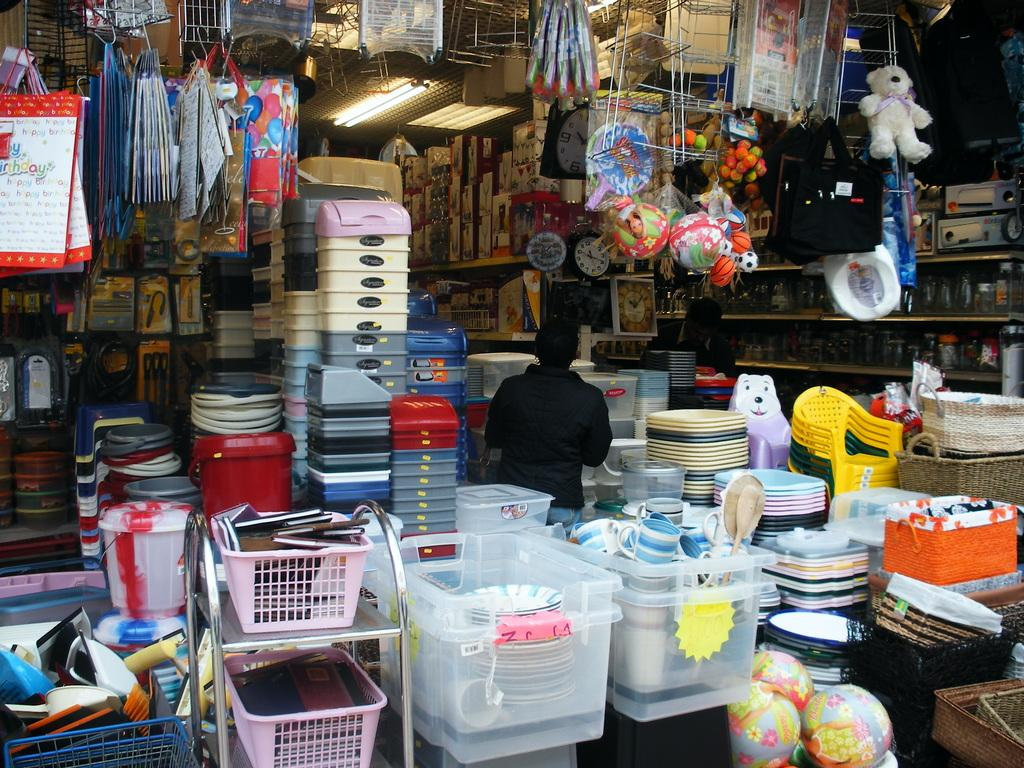<image>
Write a terse but informative summary of the picture. Front of a stand which says "birthdays" on a calendar. 